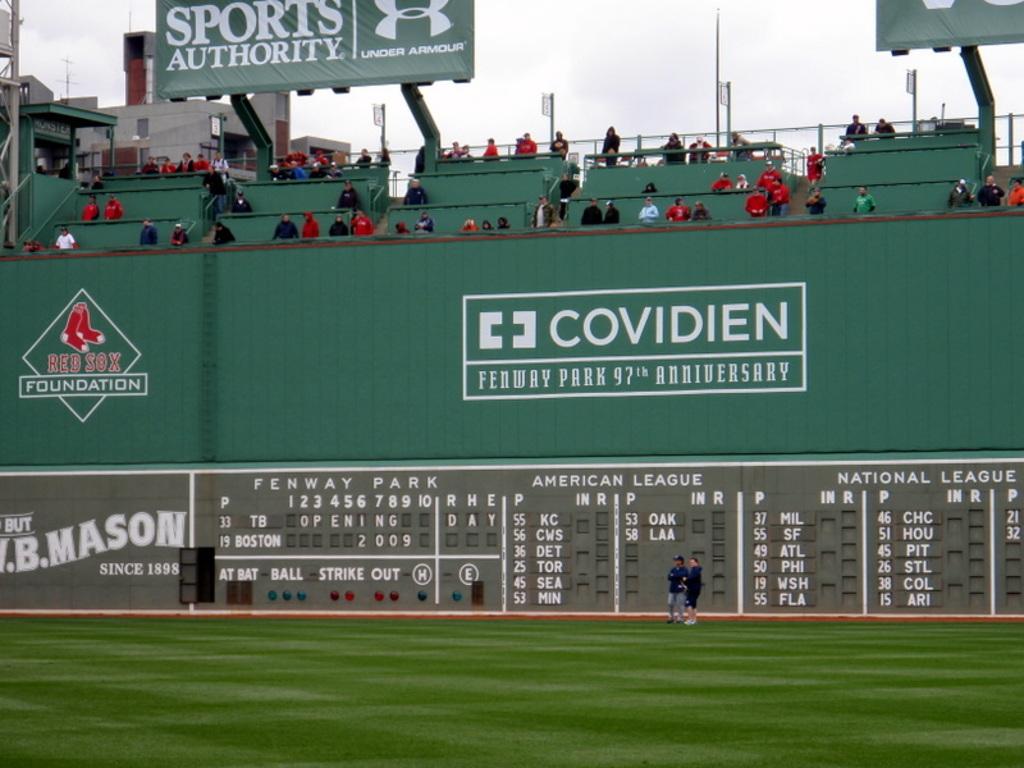What is the name of the sports store on the board?
Your response must be concise. Sports authority. 